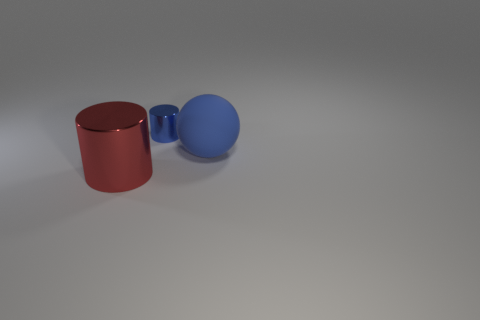Do the matte sphere and the tiny metal cylinder have the same color?
Ensure brevity in your answer.  Yes. How many big blue matte spheres are behind the shiny thing that is in front of the small metal cylinder behind the big ball?
Your response must be concise. 1. There is a cylinder that is behind the metallic object that is to the left of the tiny blue metal thing; what is its material?
Give a very brief answer. Metal. Are there any large yellow metallic objects of the same shape as the large red metal object?
Offer a terse response. No. The metal object that is the same size as the blue ball is what color?
Offer a terse response. Red. What number of things are either shiny things behind the big blue thing or objects that are to the right of the big red cylinder?
Keep it short and to the point. 2. What number of things are blue matte objects or cylinders?
Give a very brief answer. 3. There is a thing that is both behind the red shiny object and to the left of the large blue matte sphere; what size is it?
Your response must be concise. Small. What number of red balls are the same material as the red cylinder?
Your answer should be very brief. 0. There is another cylinder that is made of the same material as the tiny cylinder; what color is it?
Your response must be concise. Red. 